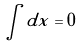<formula> <loc_0><loc_0><loc_500><loc_500>\int d x = 0</formula> 